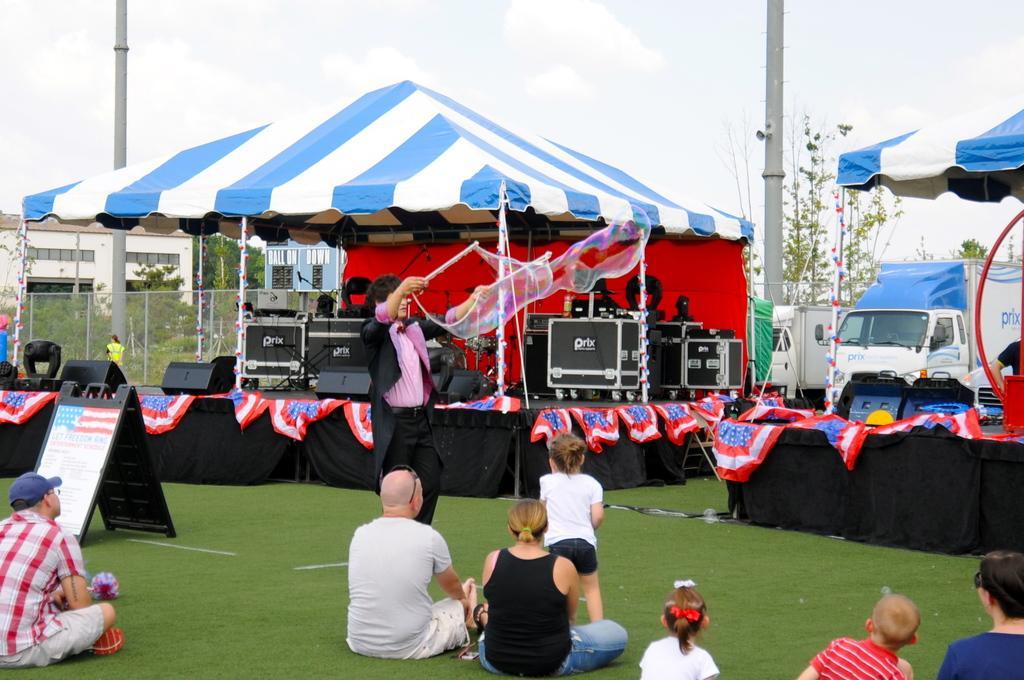Could you give a brief overview of what you see in this image? In this image there are tents. At the bottom we can see people sitting and there is a board. In the center there is a man standing and blowing bubbles. There are speakers and some equipment. We can see vehicles. In the background there are trees, poles, building and sky. 